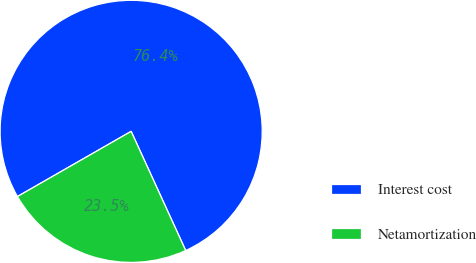Convert chart. <chart><loc_0><loc_0><loc_500><loc_500><pie_chart><fcel>Interest cost<fcel>Netamortization<nl><fcel>76.45%<fcel>23.55%<nl></chart> 